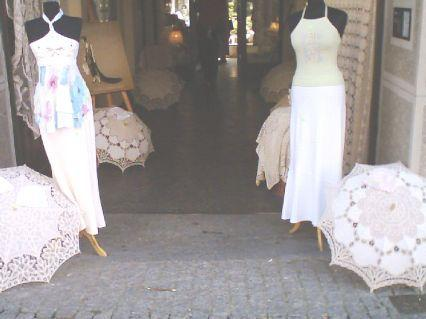How many dresses are sat around the entryway to the hall? two 